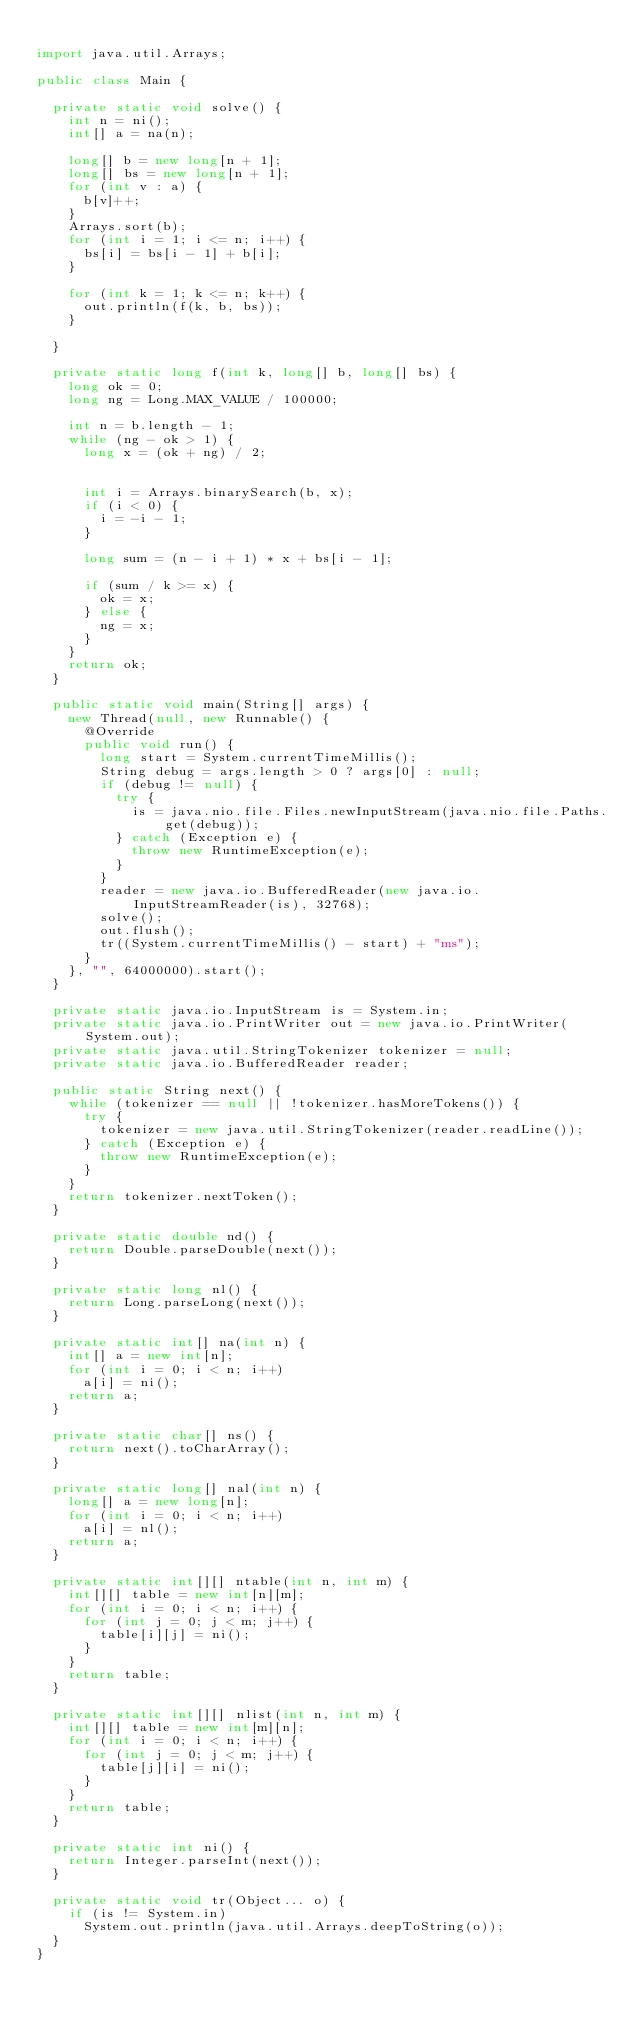Convert code to text. <code><loc_0><loc_0><loc_500><loc_500><_Java_>
import java.util.Arrays;

public class Main {

  private static void solve() {
    int n = ni();
    int[] a = na(n);

    long[] b = new long[n + 1];
    long[] bs = new long[n + 1];
    for (int v : a) {
      b[v]++;
    }
    Arrays.sort(b);
    for (int i = 1; i <= n; i++) {
      bs[i] = bs[i - 1] + b[i];
    }

    for (int k = 1; k <= n; k++) {
      out.println(f(k, b, bs));
    }

  }

  private static long f(int k, long[] b, long[] bs) {
    long ok = 0;
    long ng = Long.MAX_VALUE / 100000;

    int n = b.length - 1;
    while (ng - ok > 1) {
      long x = (ok + ng) / 2;


      int i = Arrays.binarySearch(b, x);
      if (i < 0) {
        i = -i - 1;
      }

      long sum = (n - i + 1) * x + bs[i - 1];

      if (sum / k >= x) {
        ok = x;
      } else {
        ng = x;
      }
    }
    return ok;
  }

  public static void main(String[] args) {
    new Thread(null, new Runnable() {
      @Override
      public void run() {
        long start = System.currentTimeMillis();
        String debug = args.length > 0 ? args[0] : null;
        if (debug != null) {
          try {
            is = java.nio.file.Files.newInputStream(java.nio.file.Paths.get(debug));
          } catch (Exception e) {
            throw new RuntimeException(e);
          }
        }
        reader = new java.io.BufferedReader(new java.io.InputStreamReader(is), 32768);
        solve();
        out.flush();
        tr((System.currentTimeMillis() - start) + "ms");
      }
    }, "", 64000000).start();
  }

  private static java.io.InputStream is = System.in;
  private static java.io.PrintWriter out = new java.io.PrintWriter(System.out);
  private static java.util.StringTokenizer tokenizer = null;
  private static java.io.BufferedReader reader;

  public static String next() {
    while (tokenizer == null || !tokenizer.hasMoreTokens()) {
      try {
        tokenizer = new java.util.StringTokenizer(reader.readLine());
      } catch (Exception e) {
        throw new RuntimeException(e);
      }
    }
    return tokenizer.nextToken();
  }

  private static double nd() {
    return Double.parseDouble(next());
  }

  private static long nl() {
    return Long.parseLong(next());
  }

  private static int[] na(int n) {
    int[] a = new int[n];
    for (int i = 0; i < n; i++)
      a[i] = ni();
    return a;
  }

  private static char[] ns() {
    return next().toCharArray();
  }

  private static long[] nal(int n) {
    long[] a = new long[n];
    for (int i = 0; i < n; i++)
      a[i] = nl();
    return a;
  }

  private static int[][] ntable(int n, int m) {
    int[][] table = new int[n][m];
    for (int i = 0; i < n; i++) {
      for (int j = 0; j < m; j++) {
        table[i][j] = ni();
      }
    }
    return table;
  }

  private static int[][] nlist(int n, int m) {
    int[][] table = new int[m][n];
    for (int i = 0; i < n; i++) {
      for (int j = 0; j < m; j++) {
        table[j][i] = ni();
      }
    }
    return table;
  }

  private static int ni() {
    return Integer.parseInt(next());
  }

  private static void tr(Object... o) {
    if (is != System.in)
      System.out.println(java.util.Arrays.deepToString(o));
  }
}

</code> 